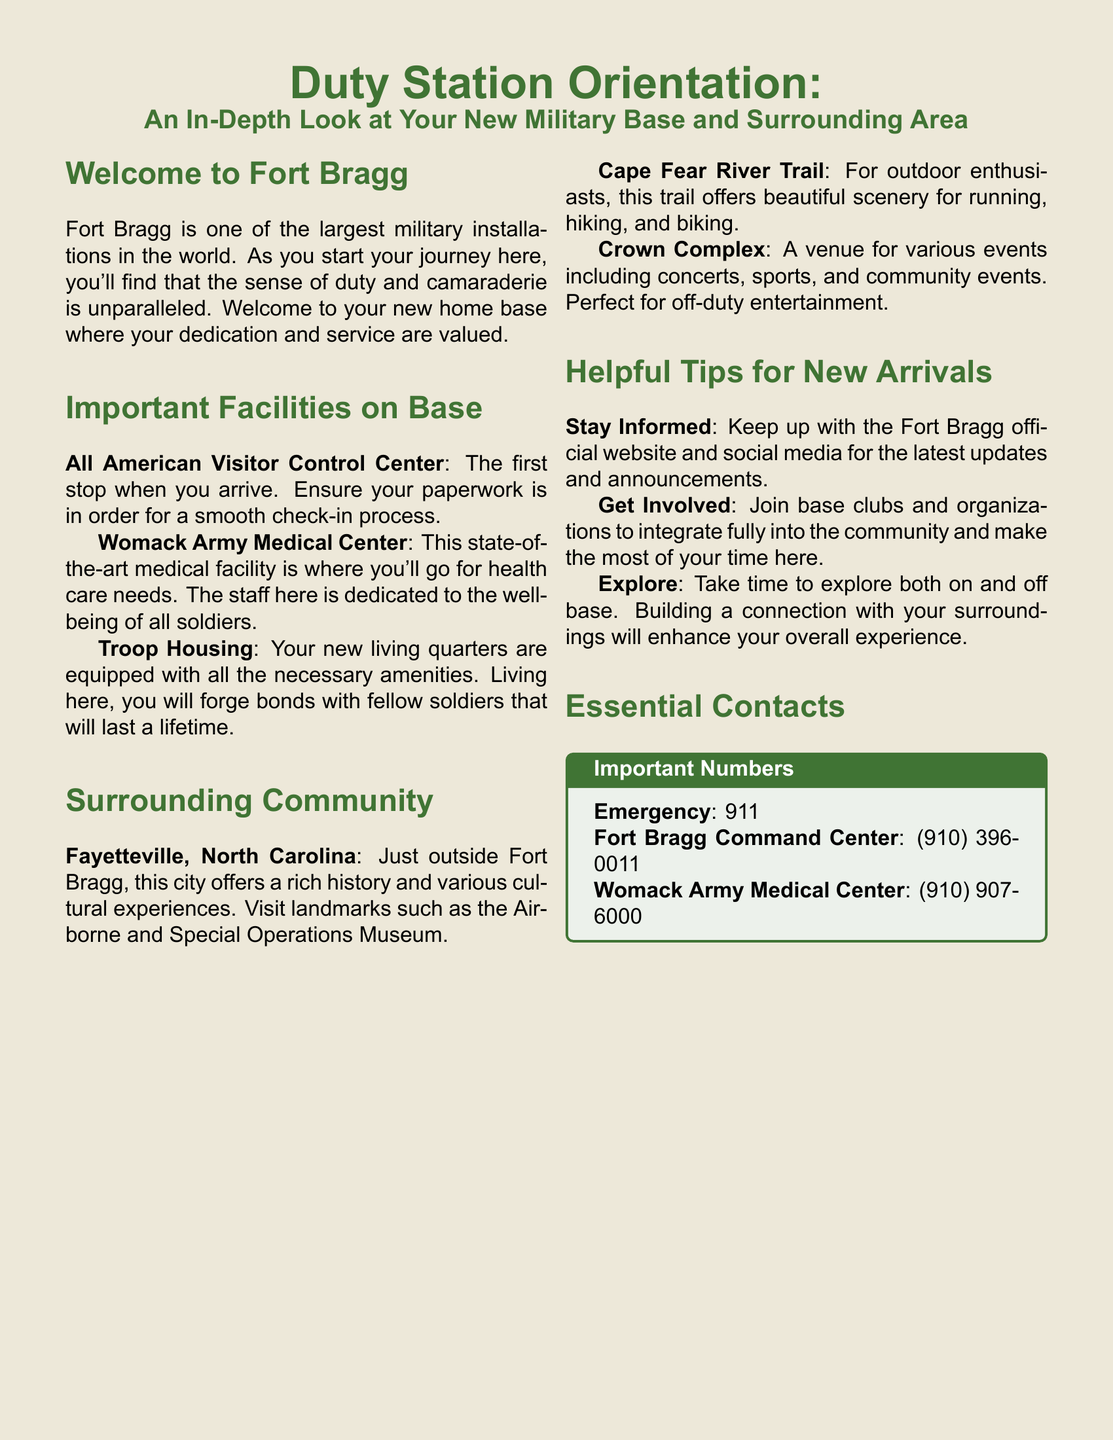What is the first stop when you arrive at Fort Bragg? The document states that the All American Visitor Control Center is the first stop upon arrival.
Answer: All American Visitor Control Center What is the contact number for Womack Army Medical Center? The document provides the phone number for Womack Army Medical Center, which is mentioned in the Essential Contacts section.
Answer: (910) 907-6000 What outdoor activity is highlighted near Fort Bragg? The document mentions the Cape Fear River Trail as a spot for outdoor activities like running, hiking, and biking.
Answer: Cape Fear River Trail Which facility is dedicated to the well-being of soldiers? According to the document, Womack Army Medical Center is a state-of-the-art facility focused on soldiers' health care needs.
Answer: Womack Army Medical Center What should new arrivals do to stay informed? The Helpful Tips section suggests keeping up with the Fort Bragg official website and social media for updates.
Answer: Keep up with the Fort Bragg official website and social media How many important numbers are listed in the document? The document contains three important numbers listed in the Essential Contacts section.
Answer: Three 